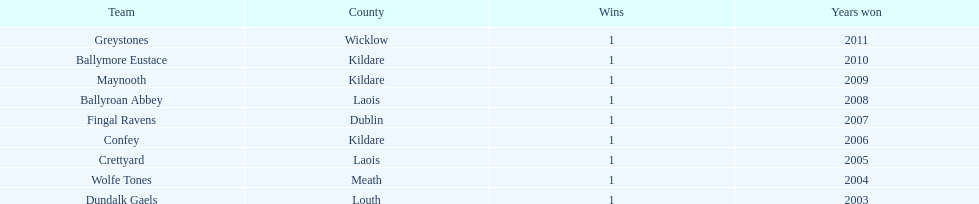What is the location of ballymore eustace? Kildare. What other teams come from kildare besides ballymore eustace? Maynooth, Confey. Among maynooth and confey, who emerged as the winner in 2009? Maynooth. 